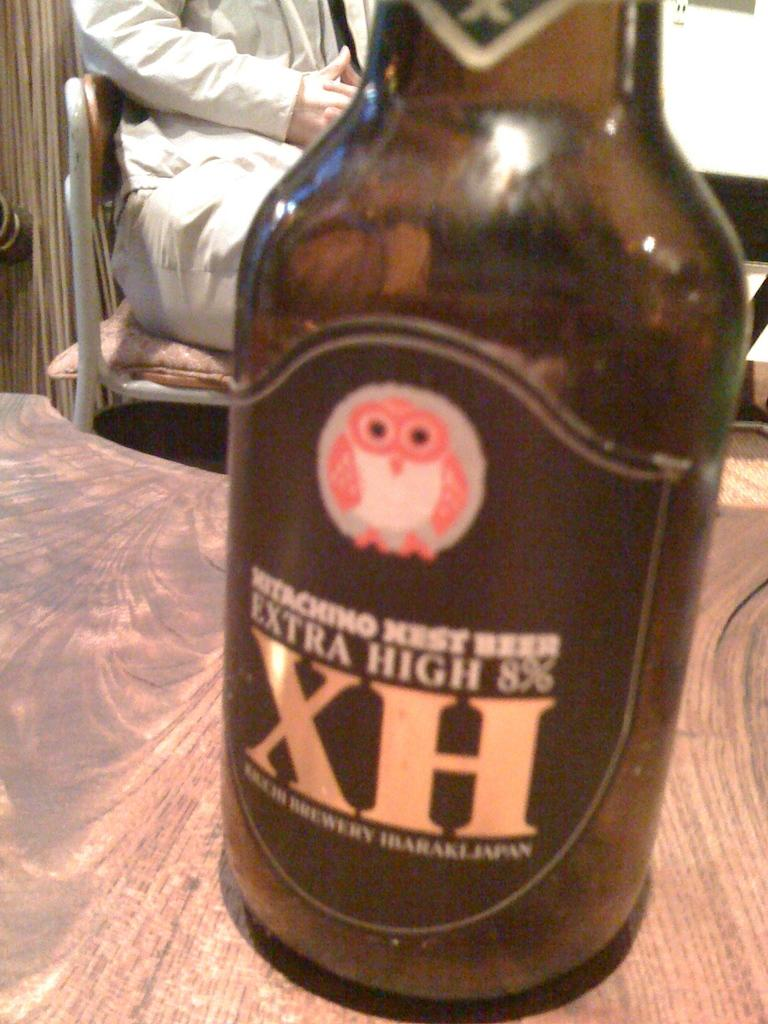What object is on the table in the image? There is a drink bottle on the table. Can you describe the person in the image? The person in the image is wearing a blue dress. What is the person doing in the image? The person is sitting in a chair. Where is the chair located in relation to the table? The chair is behind the table. What song is the person singing in the image? There is no indication in the image that the person is singing a song. 